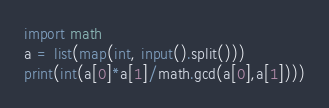Convert code to text. <code><loc_0><loc_0><loc_500><loc_500><_Python_>import math
a = list(map(int, input().split()))
print(int(a[0]*a[1]/math.gcd(a[0],a[1])))</code> 